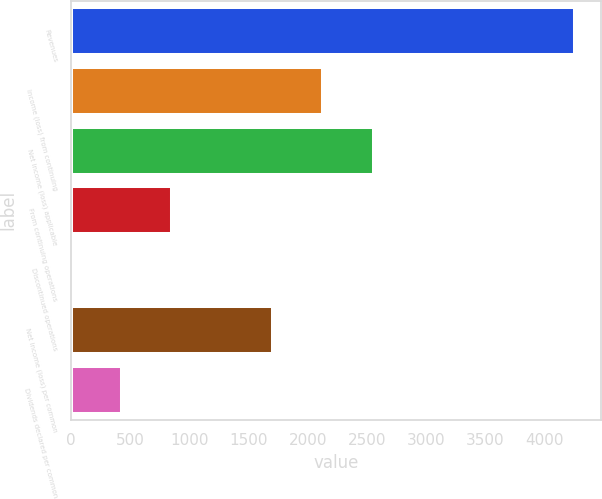Convert chart. <chart><loc_0><loc_0><loc_500><loc_500><bar_chart><fcel>Revenues<fcel>Income (loss) from continuing<fcel>Net income (loss) applicable<fcel>From continuing operations<fcel>Discontinued operations<fcel>Net income (loss) per common<fcel>Dividends declared per common<nl><fcel>4265<fcel>2132.55<fcel>2559.04<fcel>853.08<fcel>0.1<fcel>1706.06<fcel>426.59<nl></chart> 